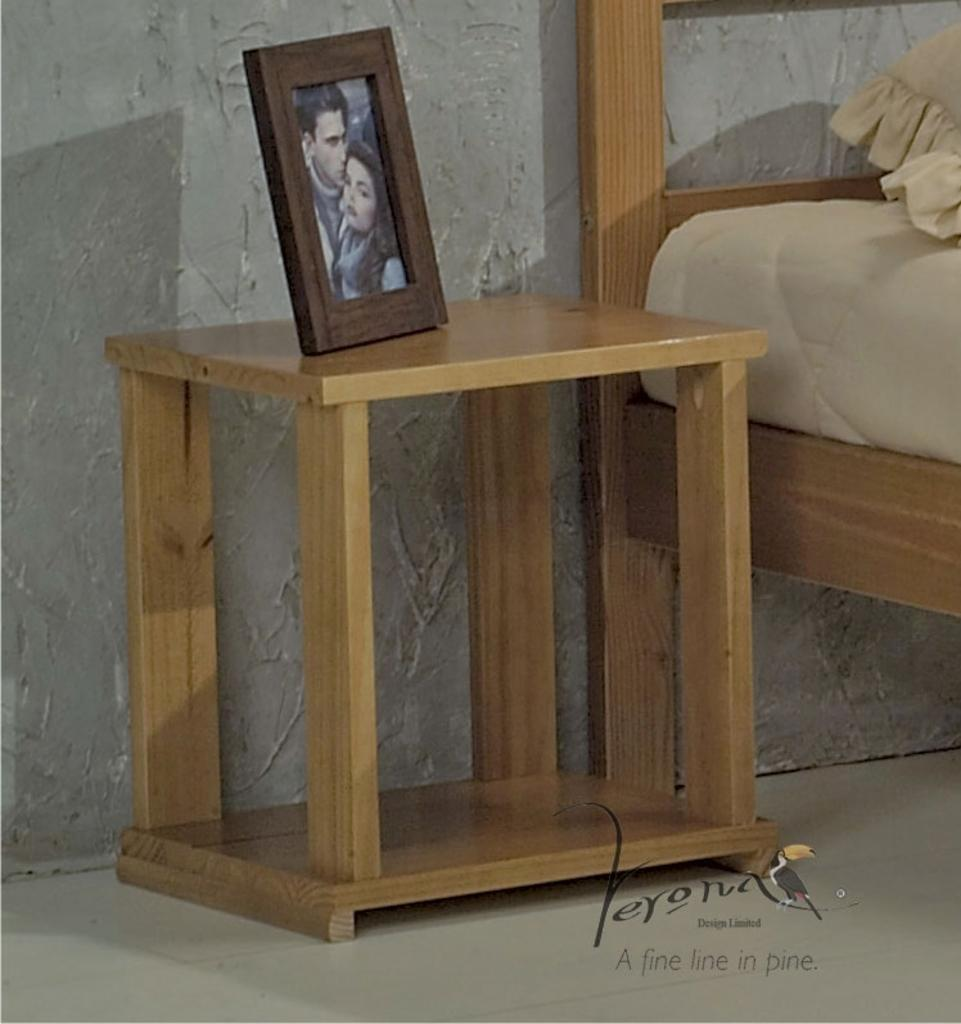What type of surface is visible in the image? There is a floor in the image. What piece of furniture can be seen in the image? There is a wooden table in the image. What is placed on the wooden table? A photo frame is present on the wooden table. What type of furniture is used for sleeping in the image? There is a bed in the image. What is placed on the bed for comfort? A pillow is on the bed. What color is the wall in the background of the image? The wall in the background is grey in color. How many boats are visible in the image? There are no boats present in the image. What type of animal is grazing near the bed in the image? There is no animal, such as a yak, present in the image. 